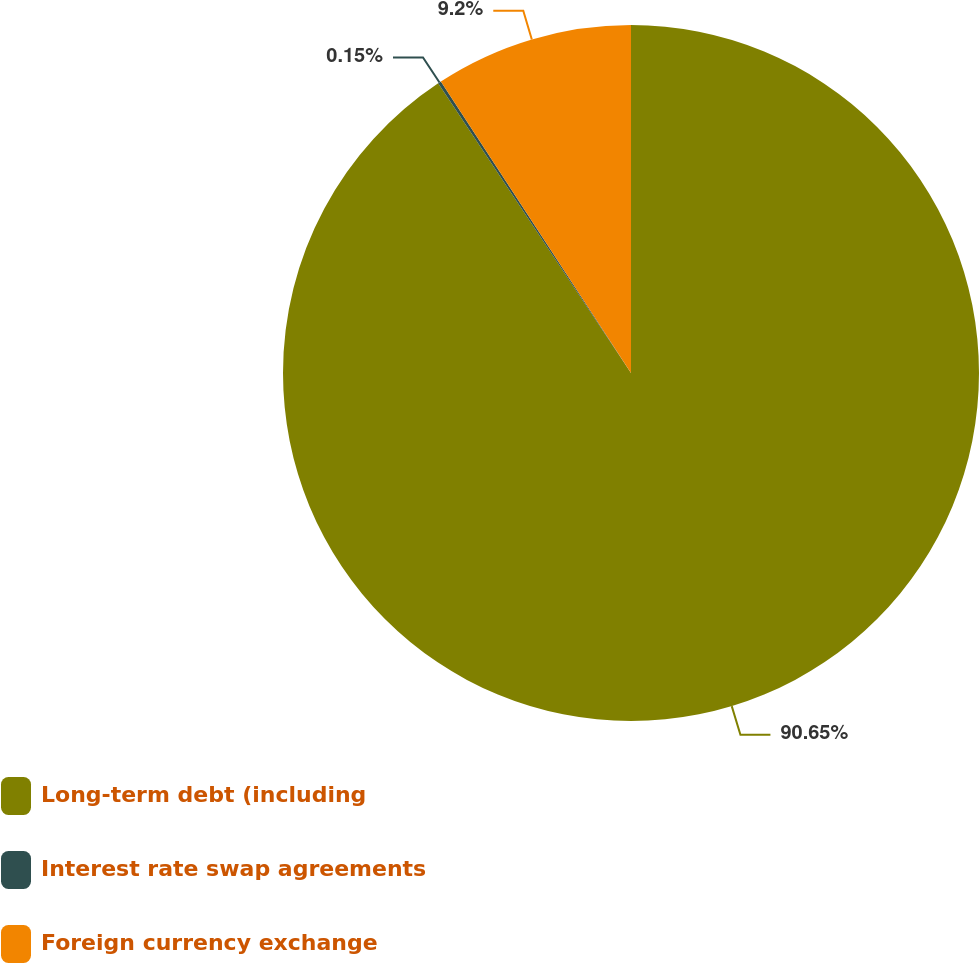Convert chart to OTSL. <chart><loc_0><loc_0><loc_500><loc_500><pie_chart><fcel>Long-term debt (including<fcel>Interest rate swap agreements<fcel>Foreign currency exchange<nl><fcel>90.66%<fcel>0.15%<fcel>9.2%<nl></chart> 